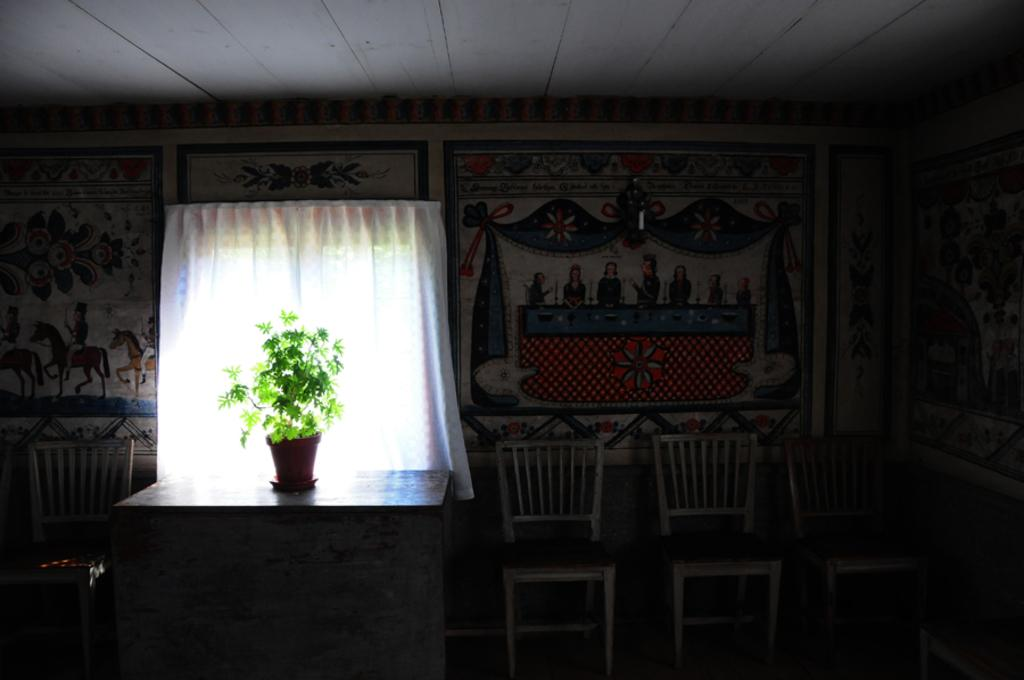What piece of furniture is present in the image? There is a table in the image. What is placed on the table? There is a plant in a pot on the table. What type of seating is visible in the image? There are chairs in the image. What can be seen on the wall in the image? There is art on the wall in the image. What part of the room's structure is visible in the image? The roof is visible in the image. What type of window treatment is present in the image? There are curtains in the image. What type of waste can be seen on the floor in the image? There is no waste present on the floor in the image. What type of string is used to hang the art on the wall in the image? There is no mention of string being used to hang the art on the wall in the image. 